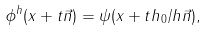Convert formula to latex. <formula><loc_0><loc_0><loc_500><loc_500>\phi ^ { h } ( x + t \vec { n } ) = \psi ( x + t h _ { 0 } / h \vec { n } ) ,</formula> 